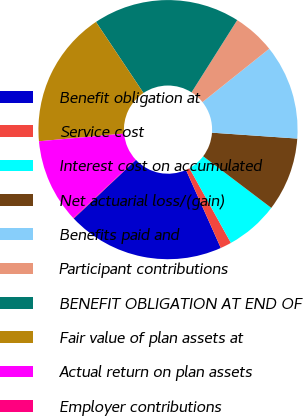<chart> <loc_0><loc_0><loc_500><loc_500><pie_chart><fcel>Benefit obligation at<fcel>Service cost<fcel>Interest cost on accumulated<fcel>Net actuarial loss/(gain)<fcel>Benefits paid and<fcel>Participant contributions<fcel>BENEFIT OBLIGATION AT END OF<fcel>Fair value of plan assets at<fcel>Actual return on plan assets<fcel>Employer contributions<nl><fcel>19.65%<fcel>1.39%<fcel>6.61%<fcel>9.22%<fcel>11.83%<fcel>5.3%<fcel>18.35%<fcel>17.05%<fcel>10.52%<fcel>0.08%<nl></chart> 